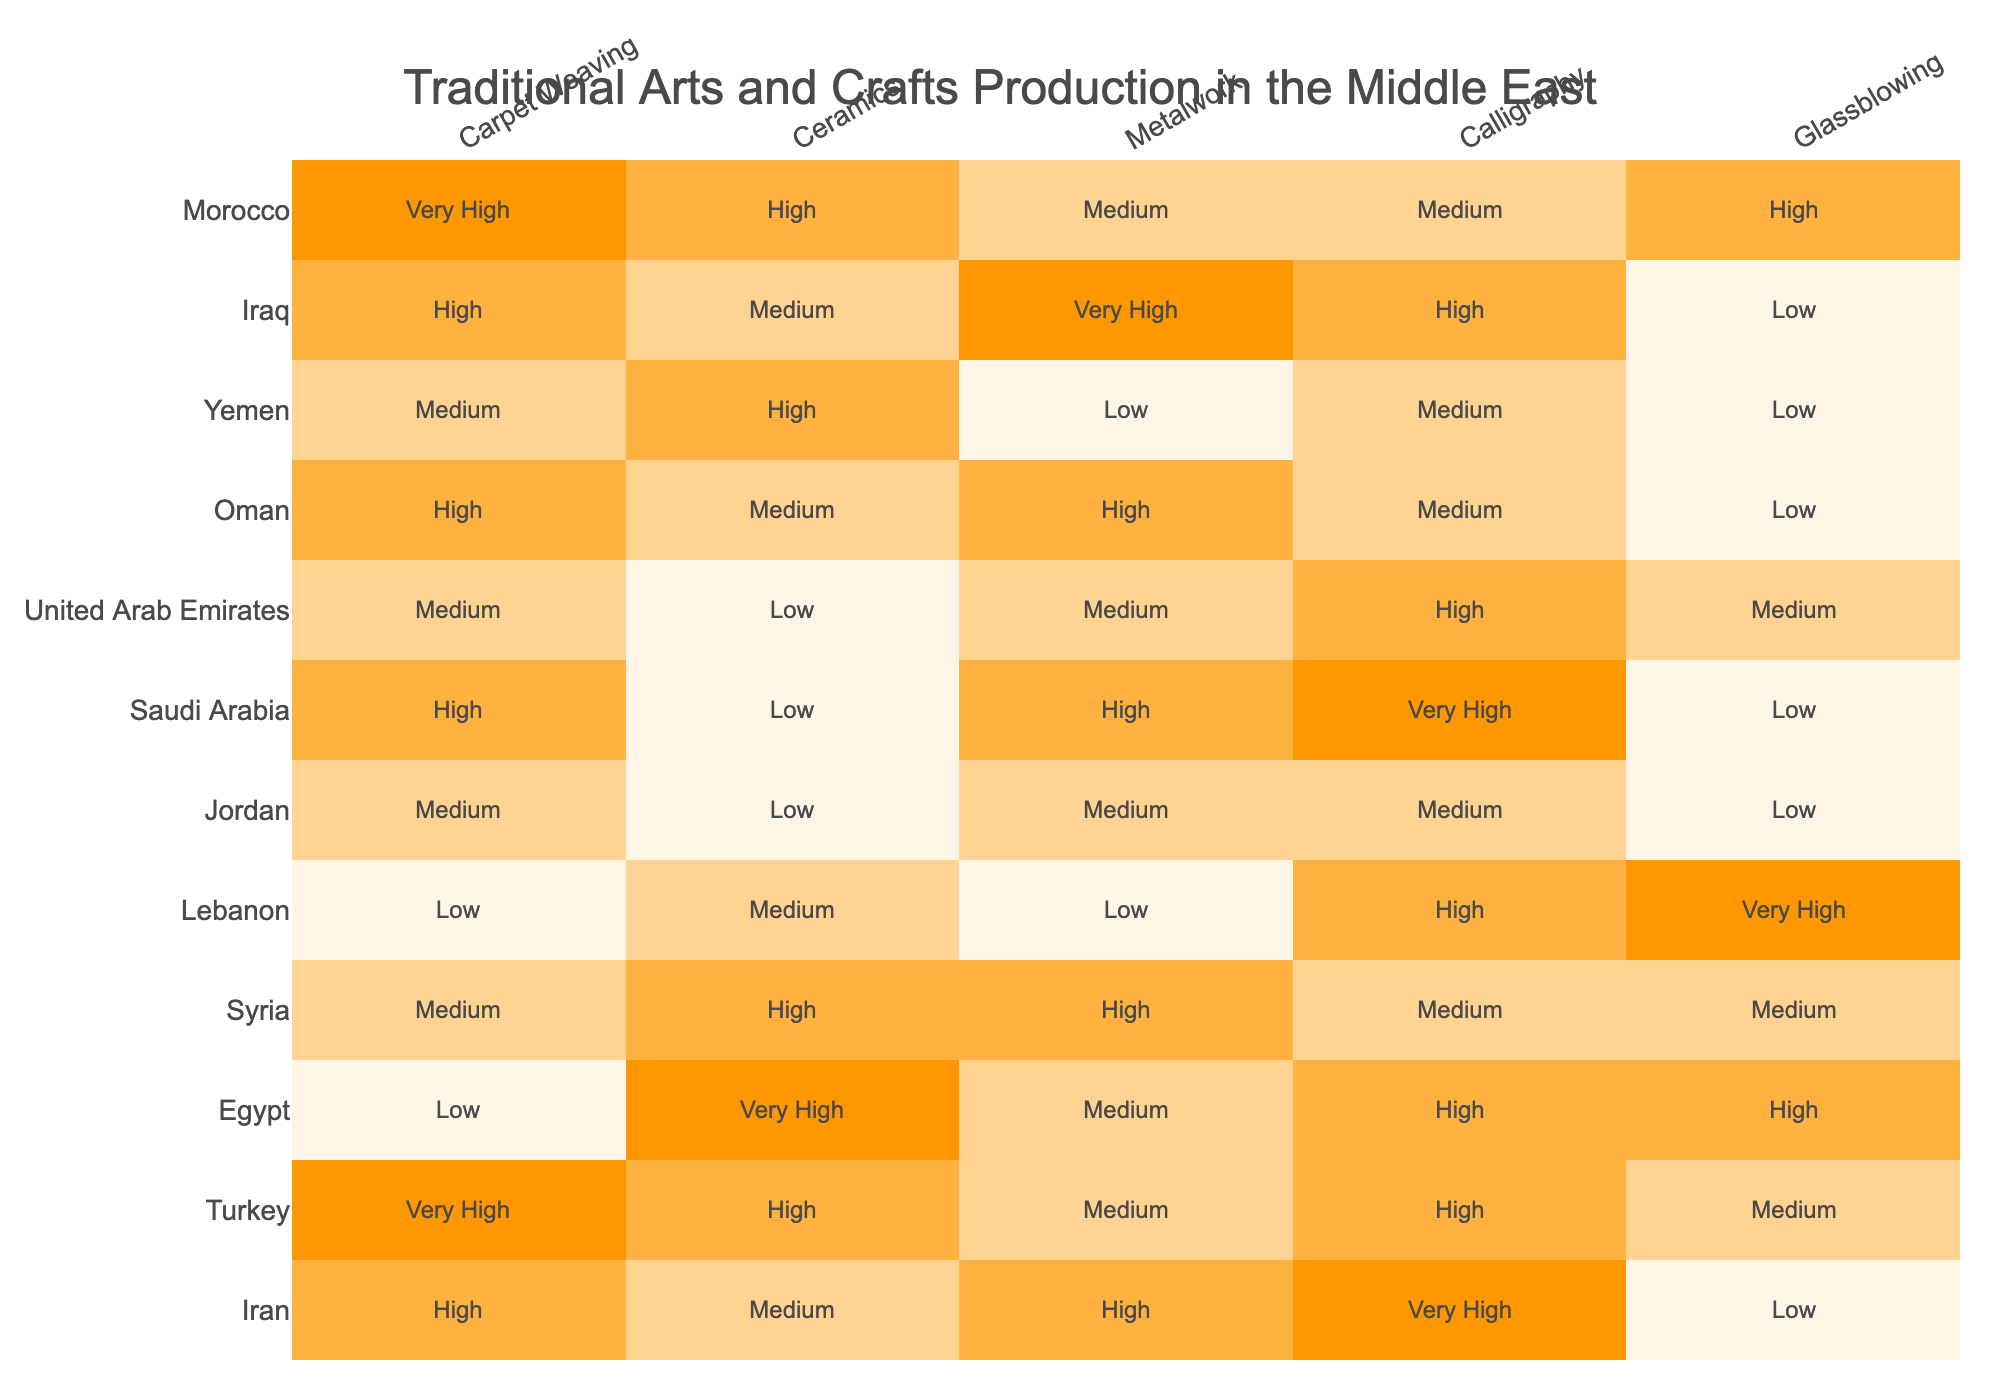What region has the highest production in calligraphy? By looking at the table, I see that the region with the highest production in calligraphy is Saudi Arabia, which is marked as 'Very High'.
Answer: Saudi Arabia Which medium has the lowest production overall across the regions? From the table, I can see that glassblowing has the lowest production, as the highest rating is only 'Medium' in two regions, while the rest are marked as 'Low'.
Answer: Glassblowing How does Egypt's ceramics production compare to Syria's? Egypt has a 'Very High' rating in ceramics, while Syria has a 'High' rating. Therefore, Egypt's ceramics production is better than Syria's.
Answer: Egypt has better ceramics production Is there a region where all mediums have medium production? By checking the production levels of all mediums for each region, I find that Jordan has only 'Medium' ratings across the board, confirming that it meets the criteria.
Answer: Yes, Jordan What is the average production level for carpet weaving across all regions? To calculate the average for carpet weaving, I convert the ratings: Very High (4), High (3), Medium (2), Low (1). For carpet weaving: Iran(3) + Turkey(4) + Egypt(1) + Syria(2) + Lebanon(1) + Jordan(2) + Saudi Arabia(3) + UAE(2) + Oman(3) + Yemen(2) + Iraq(3) + Morocco(4) = 29. There are 11 regions, so the average is 29/11 approximately equals 2.64, which is between Medium and High.
Answer: Approximately 2.6 Which region has a high level of both ceramics and calligraphy production? Examining the values, Turkey has 'High' for both ceramics and calligraphy, making it the region that meets this requirement.
Answer: Turkey How does the metalwork production in Iraq compare to that in Lebanon? Iraq has a 'Very High' rating in metalwork, while Lebanon has a 'Low' rating. This indicates that Iraq's metalwork production is significantly higher than Lebanon's.
Answer: Iraq has higher metalwork production What is the difference between Iran and Morocco in terms of carpet weaving production? Iran has a 'High' level of carpet weaving (3), and Morocco has a 'Very High' level (4). The difference in their production levels is 4 - 3 = 1 rating, indicating Morocco has one level higher.
Answer: A difference of 1 rating level 